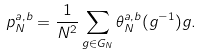<formula> <loc_0><loc_0><loc_500><loc_500>p _ { N } ^ { a , b } = \frac { 1 } { N ^ { 2 } } \sum _ { g \in G _ { N } } \theta _ { N } ^ { a , b } ( g ^ { - 1 } ) g .</formula> 